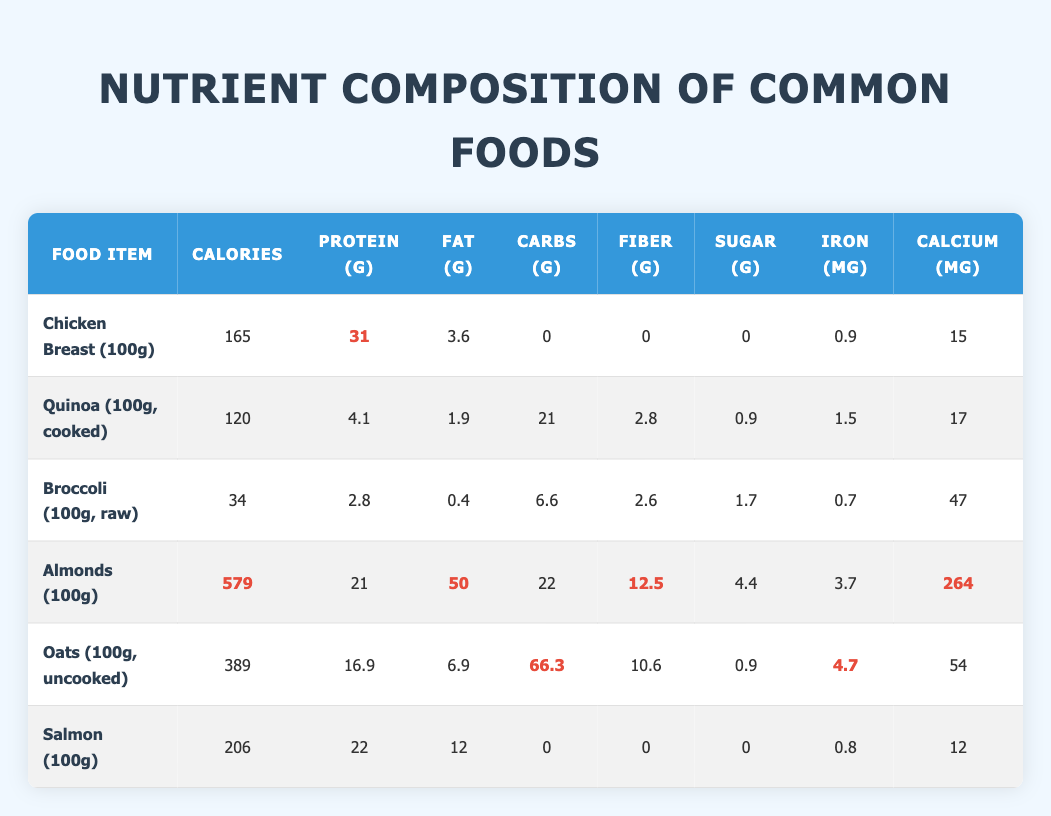What is the protein content in Chicken Breast? The protein content for Chicken Breast (100g) is listed directly in the table under the "Protein (g)" column, which shows 31g of protein.
Answer: 31g Which food has the highest amount of calories? Looking at the "Calories" column, the food item with the highest calorie content is Almonds (100g) with 579 calories.
Answer: Almonds (100g) How much more fat is in Salmon compared to Chicken Breast? From the "Fat (g)" column, Salmon has 12g of fat and Chicken Breast has 3.6g. The difference is 12g - 3.6g = 8.4g.
Answer: 8.4g Is it true that Quinoa has more fiber than Broccoli? Checking the "Fiber (g)" column, Quinoa has 2.8g of fiber while Broccoli has 2.6g. Since 2.8g is greater than 2.6g, this statement is true.
Answer: True What is the total amount of iron in Almonds and Broccoli combined? The "Iron (mg)" content for Almonds is 3.7mg and for Broccoli, it is 0.7mg. Adding these together gives 3.7mg + 0.7mg = 4.4mg of iron.
Answer: 4.4mg Which food item has more carbohydrates, Oats or Quinoa? The "Carbohydrates (g)" column lists Oats at 66.3g and Quinoa at 21g. Comparing these values shows that Oats has significantly more carbohydrates than Quinoa.
Answer: Oats What is the average calcium content of Chicken Breast, Salmon, and Broccoli? The calcium values are: Chicken Breast = 15mg, Salmon = 12mg, and Broccoli = 47mg. Adding these amounts gives a total of 15 + 12 + 47 = 74mg. Dividing this by the three food items (3) gives an average of 74mg / 3 = 24.67mg.
Answer: 24.67mg Does Oats have zero sugar content? The "Sugar (g)" column shows Oats has 0.9g of sugar. Therefore, it does not have zero sugar content, making this statement false.
Answer: False Which food contributes more to daily protein requirements if a person needs 50g of protein? The protein contributions from each food based on the table are: Chicken Breast = 31g, Quinoa = 4.1g, Broccoli = 2.8g, Almonds = 21g, Oats = 16.9g, and Salmon = 22g. The highest contribution is from the Chicken Breast at 31g, and while multiple items can be combined, none reach 50g alone.
Answer: Chicken Breast (31g) 